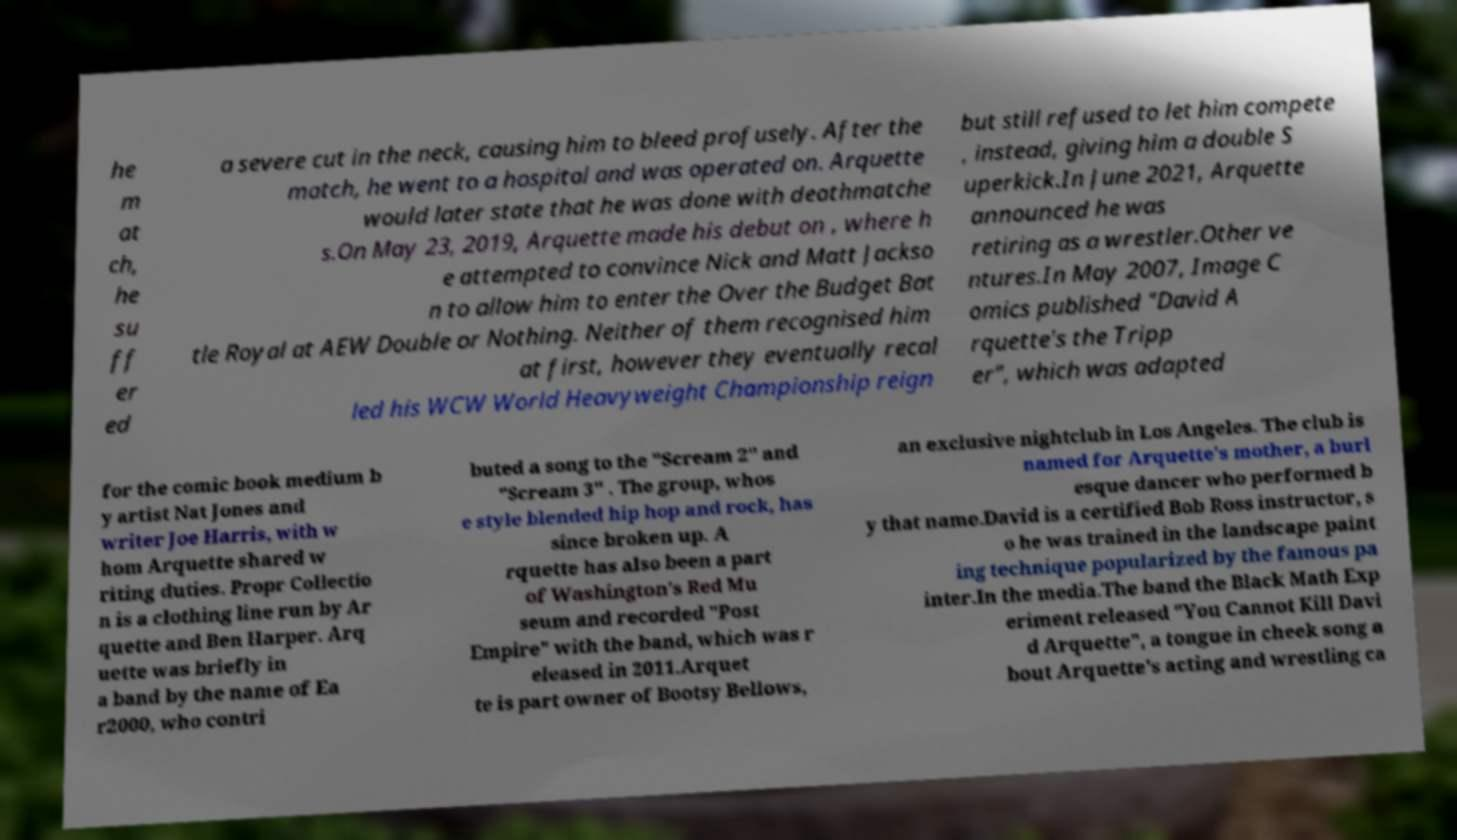I need the written content from this picture converted into text. Can you do that? he m at ch, he su ff er ed a severe cut in the neck, causing him to bleed profusely. After the match, he went to a hospital and was operated on. Arquette would later state that he was done with deathmatche s.On May 23, 2019, Arquette made his debut on , where h e attempted to convince Nick and Matt Jackso n to allow him to enter the Over the Budget Bat tle Royal at AEW Double or Nothing. Neither of them recognised him at first, however they eventually recal led his WCW World Heavyweight Championship reign but still refused to let him compete , instead, giving him a double S uperkick.In June 2021, Arquette announced he was retiring as a wrestler.Other ve ntures.In May 2007, Image C omics published "David A rquette's the Tripp er", which was adapted for the comic book medium b y artist Nat Jones and writer Joe Harris, with w hom Arquette shared w riting duties. Propr Collectio n is a clothing line run by Ar quette and Ben Harper. Arq uette was briefly in a band by the name of Ea r2000, who contri buted a song to the "Scream 2" and "Scream 3" . The group, whos e style blended hip hop and rock, has since broken up. A rquette has also been a part of Washington's Red Mu seum and recorded "Post Empire" with the band, which was r eleased in 2011.Arquet te is part owner of Bootsy Bellows, an exclusive nightclub in Los Angeles. The club is named for Arquette's mother, a burl esque dancer who performed b y that name.David is a certified Bob Ross instructor, s o he was trained in the landscape paint ing technique popularized by the famous pa inter.In the media.The band the Black Math Exp eriment released "You Cannot Kill Davi d Arquette", a tongue in cheek song a bout Arquette's acting and wrestling ca 